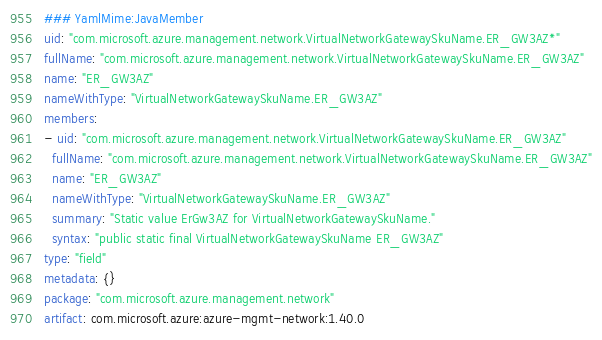Convert code to text. <code><loc_0><loc_0><loc_500><loc_500><_YAML_>### YamlMime:JavaMember
uid: "com.microsoft.azure.management.network.VirtualNetworkGatewaySkuName.ER_GW3AZ*"
fullName: "com.microsoft.azure.management.network.VirtualNetworkGatewaySkuName.ER_GW3AZ"
name: "ER_GW3AZ"
nameWithType: "VirtualNetworkGatewaySkuName.ER_GW3AZ"
members:
- uid: "com.microsoft.azure.management.network.VirtualNetworkGatewaySkuName.ER_GW3AZ"
  fullName: "com.microsoft.azure.management.network.VirtualNetworkGatewaySkuName.ER_GW3AZ"
  name: "ER_GW3AZ"
  nameWithType: "VirtualNetworkGatewaySkuName.ER_GW3AZ"
  summary: "Static value ErGw3AZ for VirtualNetworkGatewaySkuName."
  syntax: "public static final VirtualNetworkGatewaySkuName ER_GW3AZ"
type: "field"
metadata: {}
package: "com.microsoft.azure.management.network"
artifact: com.microsoft.azure:azure-mgmt-network:1.40.0
</code> 